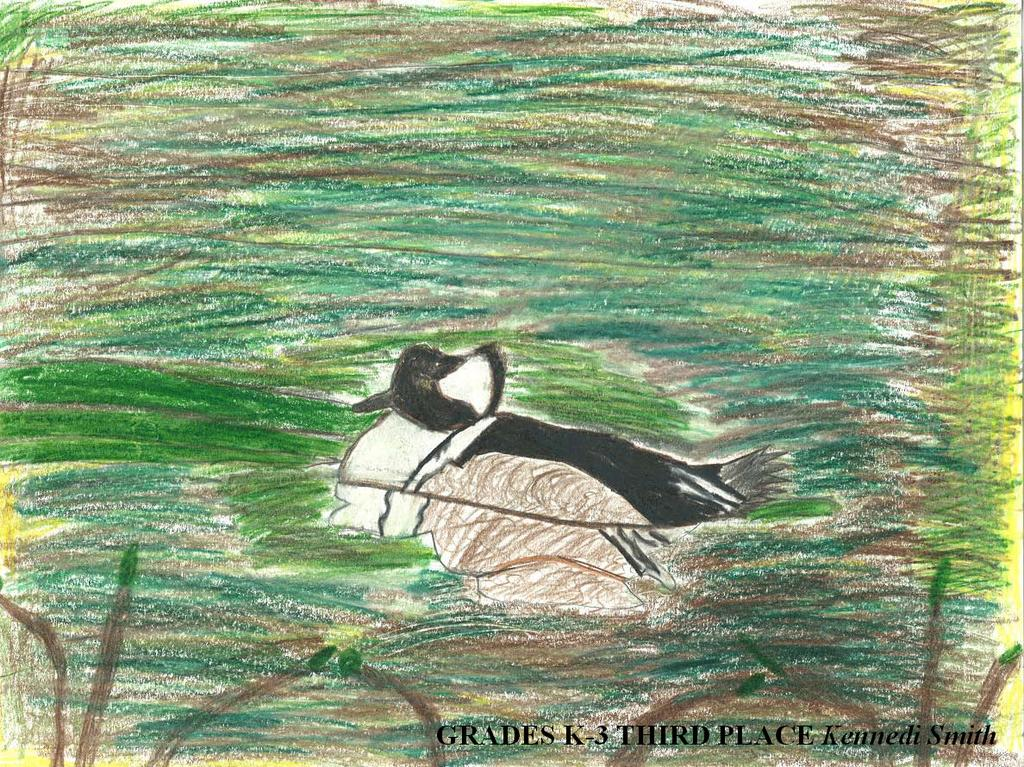What is the main subject of the painting in the image? The painting depicts a bird. What colors are used to paint the bird? The bird is white, black, and brown in color. Where is the bird located in the painting? The bird is on the surface of the water. What else can be seen in the image besides the painting? There are plants visible in the image. What type of lead can be seen in the image? There is no lead present in the image; it features a painting of a bird on the surface of the water. Is there a store visible in the image? No, there is no store present in the image. 